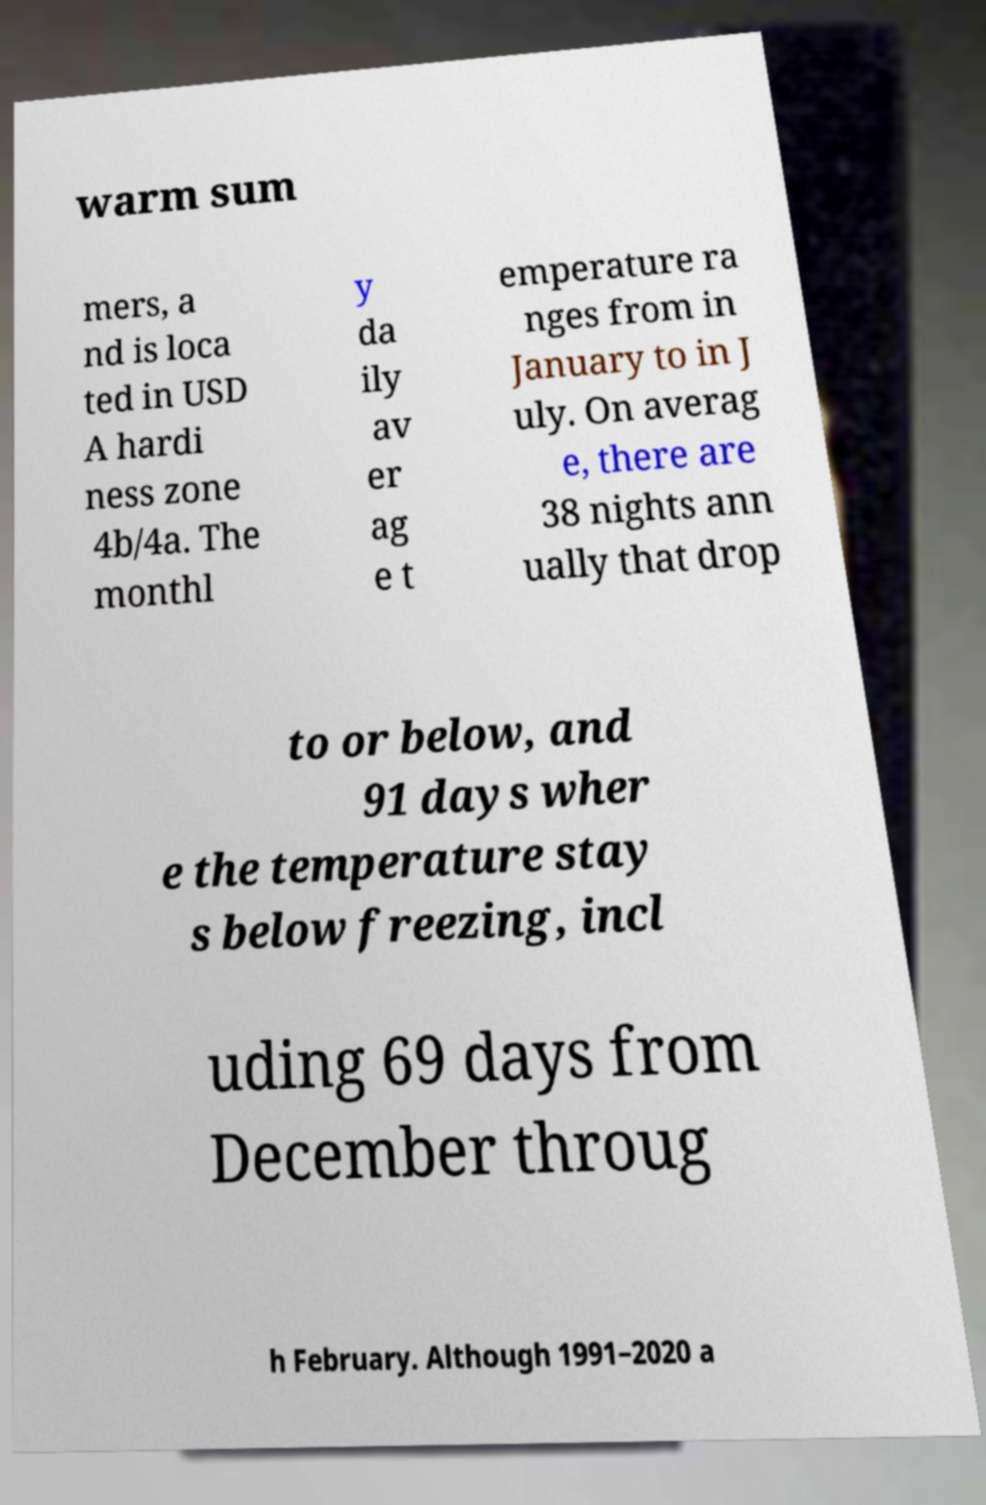I need the written content from this picture converted into text. Can you do that? warm sum mers, a nd is loca ted in USD A hardi ness zone 4b/4a. The monthl y da ily av er ag e t emperature ra nges from in January to in J uly. On averag e, there are 38 nights ann ually that drop to or below, and 91 days wher e the temperature stay s below freezing, incl uding 69 days from December throug h February. Although 1991–2020 a 